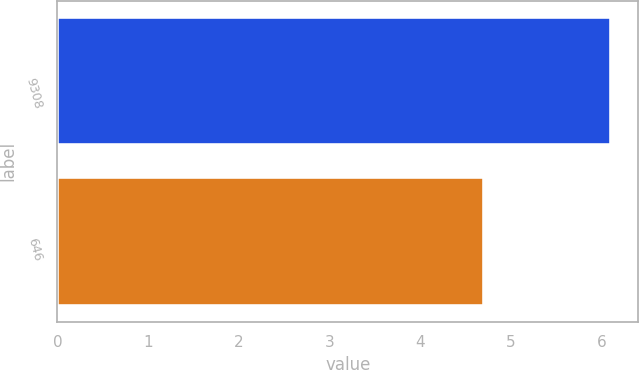Convert chart to OTSL. <chart><loc_0><loc_0><loc_500><loc_500><bar_chart><fcel>9308<fcel>646<nl><fcel>6.1<fcel>4.7<nl></chart> 